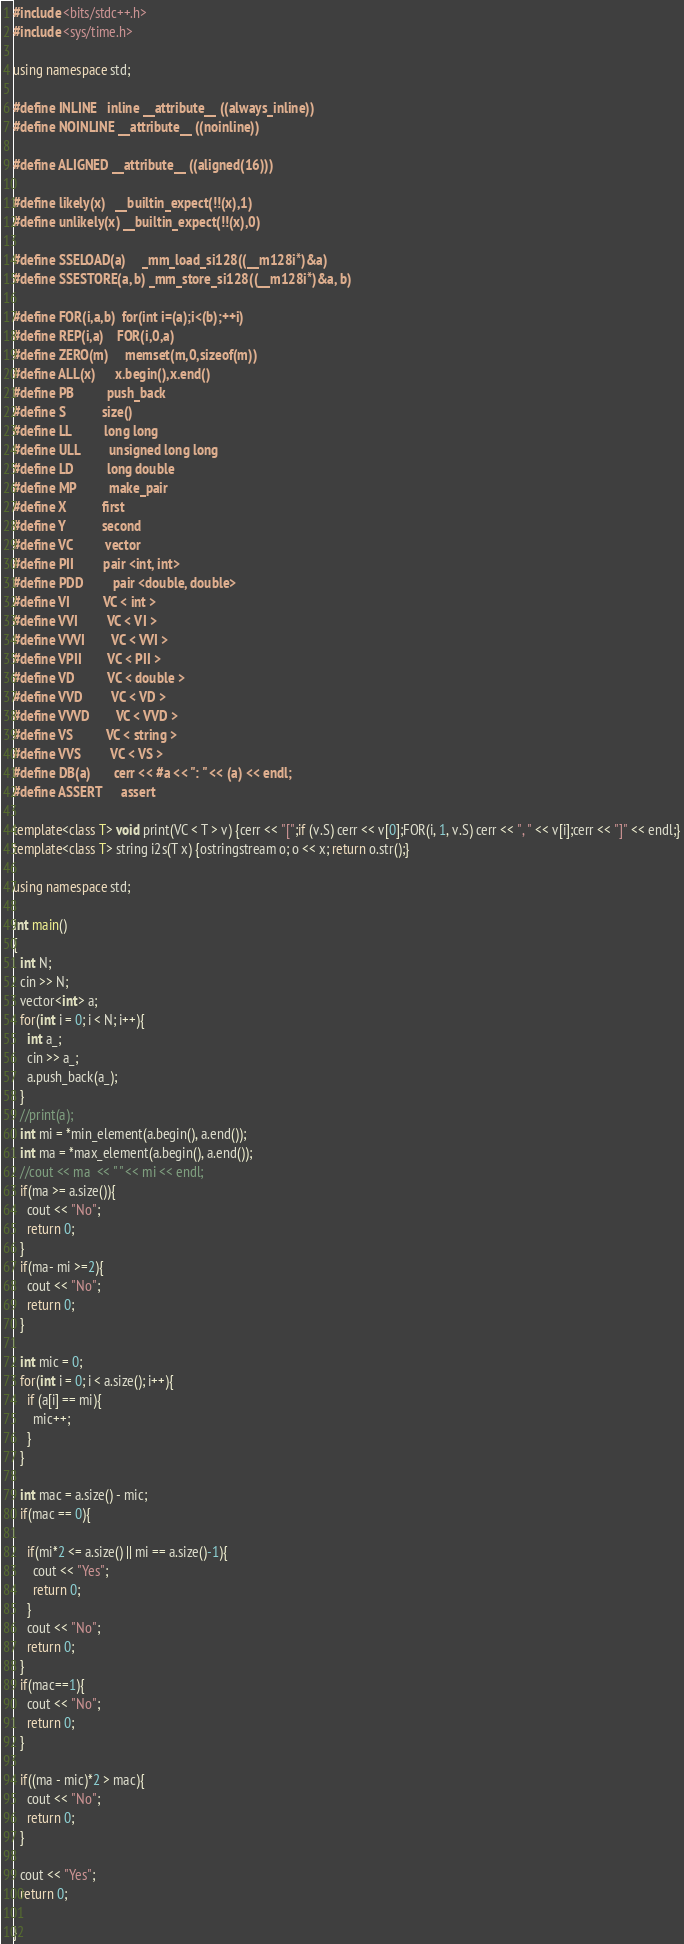<code> <loc_0><loc_0><loc_500><loc_500><_C++_>#include <bits/stdc++.h>
#include <sys/time.h>

using namespace std;

#define INLINE   inline __attribute__ ((always_inline))
#define NOINLINE __attribute__ ((noinline))

#define ALIGNED __attribute__ ((aligned(16)))

#define likely(x)   __builtin_expect(!!(x),1)
#define unlikely(x) __builtin_expect(!!(x),0)

#define SSELOAD(a)     _mm_load_si128((__m128i*)&a)
#define SSESTORE(a, b) _mm_store_si128((__m128i*)&a, b)

#define FOR(i,a,b)  for(int i=(a);i<(b);++i)
#define REP(i,a)    FOR(i,0,a)
#define ZERO(m)     memset(m,0,sizeof(m))
#define ALL(x)      x.begin(),x.end()
#define PB          push_back
#define S           size()
#define LL          long long
#define ULL         unsigned long long
#define LD          long double
#define MP          make_pair
#define X           first
#define Y           second
#define VC          vector
#define PII         pair <int, int>
#define PDD         pair <double, double>
#define VI          VC < int >
#define VVI         VC < VI >
#define VVVI        VC < VVI >
#define VPII        VC < PII >
#define VD          VC < double >
#define VVD         VC < VD >
#define VVVD        VC < VVD >
#define VS          VC < string >
#define VVS         VC < VS >
#define DB(a)       cerr << #a << ": " << (a) << endl;
#define ASSERT      assert

template<class T> void print(VC < T > v) {cerr << "[";if (v.S) cerr << v[0];FOR(i, 1, v.S) cerr << ", " << v[i];cerr << "]" << endl;}
template<class T> string i2s(T x) {ostringstream o; o << x; return o.str();}

using namespace std;

int main()
{
  int N;
  cin >> N;
  vector<int> a;
  for(int i = 0; i < N; i++){
    int a_;
    cin >> a_;
    a.push_back(a_);
  }
  //print(a);
  int mi = *min_element(a.begin(), a.end());
  int ma = *max_element(a.begin(), a.end());
  //cout << ma  << " " << mi << endl;
  if(ma >= a.size()){
    cout << "No";
    return 0;
  }
  if(ma- mi >=2){
    cout << "No";
    return 0;
  }

  int mic = 0;
  for(int i = 0; i < a.size(); i++){
    if (a[i] == mi){
      mic++;
    }
  }

  int mac = a.size() - mic;
  if(mac == 0){

    if(mi*2 <= a.size() || mi == a.size()-1){
      cout << "Yes";
      return 0;
    }
    cout << "No";
    return 0;
  }
  if(mac==1){
    cout << "No";
    return 0;
  }

  if((ma - mic)*2 > mac){
    cout << "No";
    return 0;
  }

  cout << "Yes";
  return 0;

}
</code> 